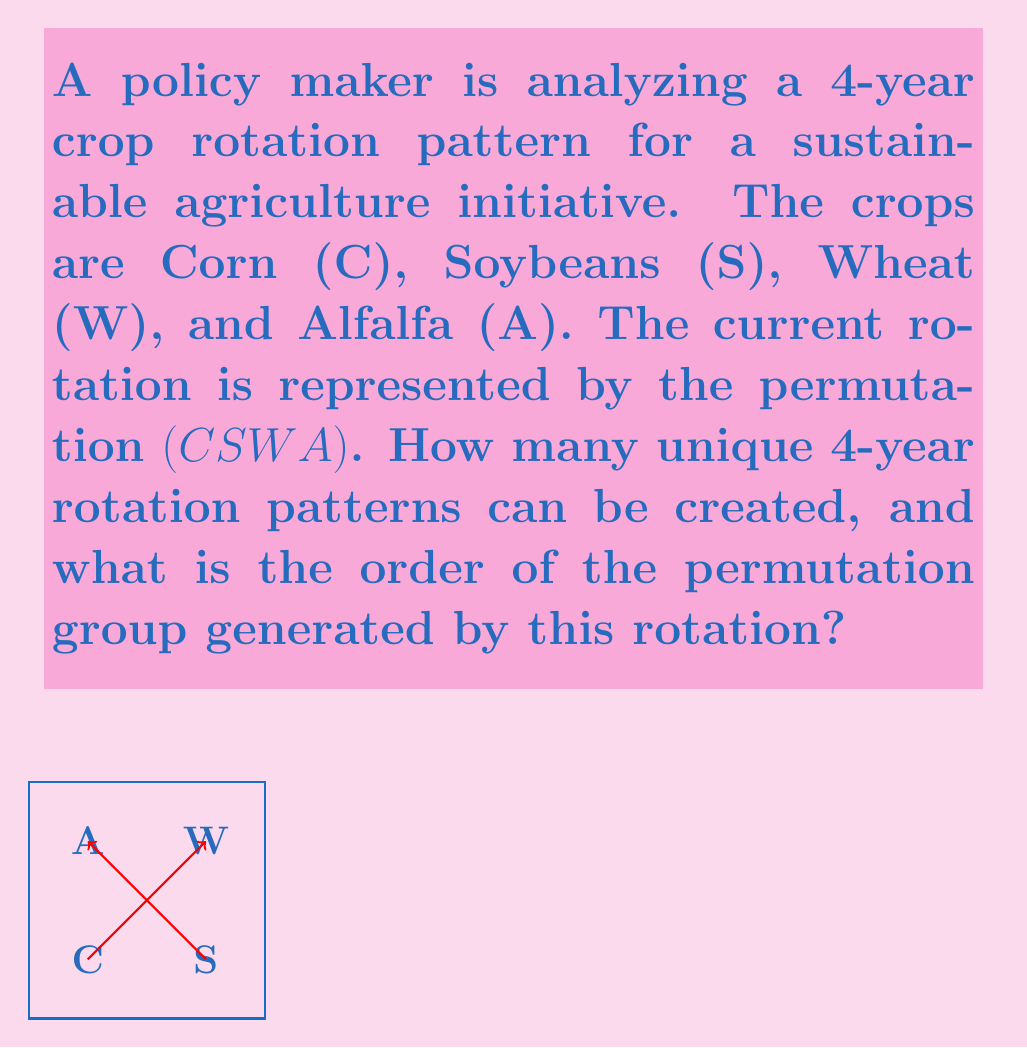What is the answer to this math problem? Let's approach this step-by-step:

1) First, we need to understand what the permutation $(C S W A)$ means. This is cycle notation, indicating that C is replaced by S, S by W, W by A, and A by C.

2) To find the number of unique 4-year rotation patterns, we need to consider all possible permutations of the 4 crops. This is given by 4! (4 factorial).

   $4! = 4 \times 3 \times 2 \times 1 = 24$

3) Now, for the order of the permutation group generated by this rotation:

   The order of a permutation is the smallest positive integer $n$ such that $\sigma^n = e$ (the identity permutation).

4) Let's apply the permutation repeatedly:
   $(C S W A)$ (original)
   $(S W A C)$ (after one application)
   $(W A C S)$ (after two applications)
   $(A C S W)$ (after three applications)
   $(C S W A)$ (after four applications, back to the original)

5) We see that after 4 applications, we return to the original order. This means the order of the permutation is 4.

6) The permutation group generated by this rotation will consist of these 4 permutations, and its order will also be 4.

Therefore, there are 24 possible unique rotation patterns, and the order of the permutation group generated by the given rotation is 4.
Answer: 24 unique patterns; group order 4 